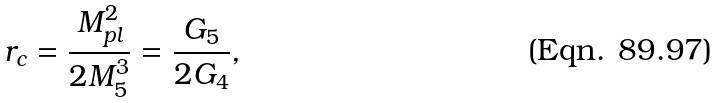<formula> <loc_0><loc_0><loc_500><loc_500>r _ { c } = \frac { M _ { p l } ^ { 2 } } { 2 M _ { 5 } ^ { 3 } } = \frac { G _ { 5 } } { 2 G _ { 4 } } ,</formula> 